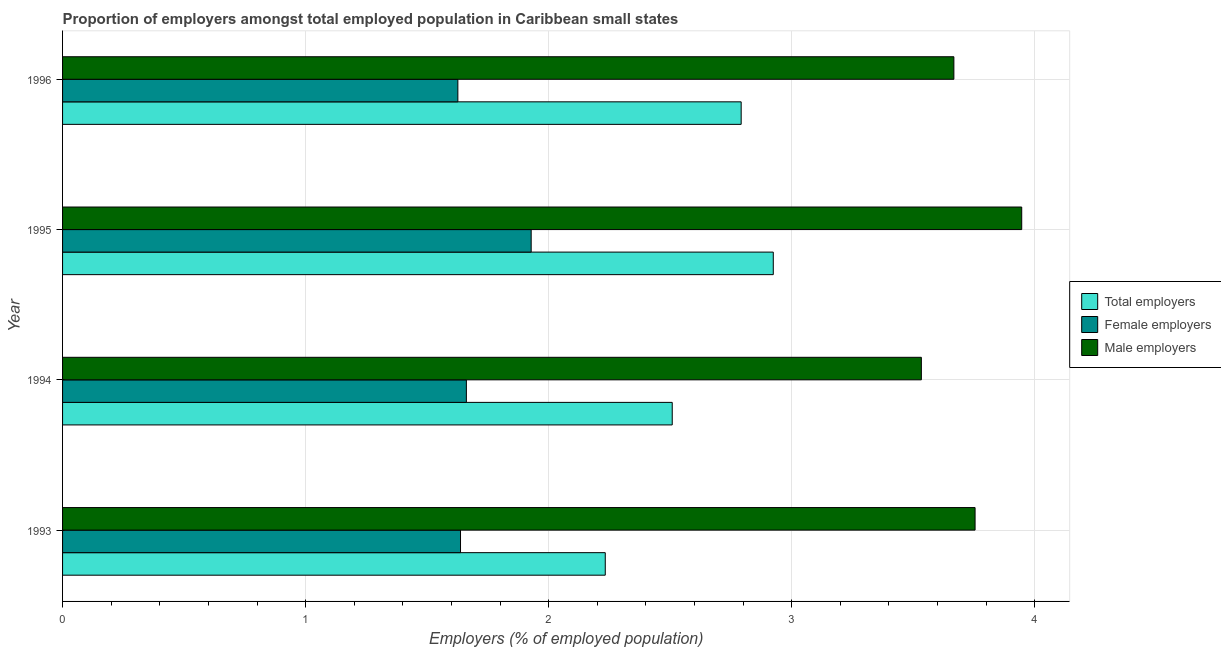Are the number of bars on each tick of the Y-axis equal?
Keep it short and to the point. Yes. How many bars are there on the 2nd tick from the top?
Offer a terse response. 3. How many bars are there on the 4th tick from the bottom?
Your response must be concise. 3. What is the label of the 1st group of bars from the top?
Offer a very short reply. 1996. What is the percentage of female employers in 1995?
Your answer should be very brief. 1.93. Across all years, what is the maximum percentage of male employers?
Your answer should be very brief. 3.95. Across all years, what is the minimum percentage of total employers?
Offer a terse response. 2.23. In which year was the percentage of female employers maximum?
Your answer should be compact. 1995. What is the total percentage of total employers in the graph?
Provide a succinct answer. 10.46. What is the difference between the percentage of female employers in 1993 and that in 1994?
Make the answer very short. -0.02. What is the difference between the percentage of male employers in 1994 and the percentage of female employers in 1996?
Provide a short and direct response. 1.91. What is the average percentage of female employers per year?
Provide a succinct answer. 1.71. In how many years, is the percentage of female employers greater than 3.2 %?
Give a very brief answer. 0. What is the ratio of the percentage of total employers in 1994 to that in 1996?
Give a very brief answer. 0.9. Is the percentage of female employers in 1993 less than that in 1996?
Offer a terse response. No. What is the difference between the highest and the second highest percentage of female employers?
Your answer should be compact. 0.27. What is the difference between the highest and the lowest percentage of total employers?
Your answer should be compact. 0.69. In how many years, is the percentage of female employers greater than the average percentage of female employers taken over all years?
Ensure brevity in your answer.  1. Is the sum of the percentage of total employers in 1995 and 1996 greater than the maximum percentage of male employers across all years?
Ensure brevity in your answer.  Yes. What does the 1st bar from the top in 1996 represents?
Keep it short and to the point. Male employers. What does the 2nd bar from the bottom in 1994 represents?
Provide a short and direct response. Female employers. How many bars are there?
Offer a very short reply. 12. Are all the bars in the graph horizontal?
Make the answer very short. Yes. How many years are there in the graph?
Your answer should be compact. 4. Does the graph contain any zero values?
Offer a very short reply. No. How are the legend labels stacked?
Make the answer very short. Vertical. What is the title of the graph?
Your answer should be compact. Proportion of employers amongst total employed population in Caribbean small states. Does "Communicable diseases" appear as one of the legend labels in the graph?
Provide a short and direct response. No. What is the label or title of the X-axis?
Offer a terse response. Employers (% of employed population). What is the Employers (% of employed population) in Total employers in 1993?
Make the answer very short. 2.23. What is the Employers (% of employed population) in Female employers in 1993?
Give a very brief answer. 1.64. What is the Employers (% of employed population) in Male employers in 1993?
Offer a terse response. 3.75. What is the Employers (% of employed population) of Total employers in 1994?
Your answer should be very brief. 2.51. What is the Employers (% of employed population) of Female employers in 1994?
Your answer should be compact. 1.66. What is the Employers (% of employed population) of Male employers in 1994?
Provide a succinct answer. 3.53. What is the Employers (% of employed population) of Total employers in 1995?
Make the answer very short. 2.92. What is the Employers (% of employed population) of Female employers in 1995?
Offer a very short reply. 1.93. What is the Employers (% of employed population) in Male employers in 1995?
Your answer should be very brief. 3.95. What is the Employers (% of employed population) of Total employers in 1996?
Your answer should be very brief. 2.79. What is the Employers (% of employed population) of Female employers in 1996?
Offer a very short reply. 1.63. What is the Employers (% of employed population) in Male employers in 1996?
Offer a very short reply. 3.67. Across all years, what is the maximum Employers (% of employed population) in Total employers?
Your answer should be compact. 2.92. Across all years, what is the maximum Employers (% of employed population) of Female employers?
Your response must be concise. 1.93. Across all years, what is the maximum Employers (% of employed population) in Male employers?
Your answer should be compact. 3.95. Across all years, what is the minimum Employers (% of employed population) in Total employers?
Your answer should be very brief. 2.23. Across all years, what is the minimum Employers (% of employed population) of Female employers?
Your answer should be compact. 1.63. Across all years, what is the minimum Employers (% of employed population) of Male employers?
Make the answer very short. 3.53. What is the total Employers (% of employed population) in Total employers in the graph?
Offer a very short reply. 10.46. What is the total Employers (% of employed population) of Female employers in the graph?
Ensure brevity in your answer.  6.85. What is the total Employers (% of employed population) of Male employers in the graph?
Provide a short and direct response. 14.9. What is the difference between the Employers (% of employed population) of Total employers in 1993 and that in 1994?
Offer a terse response. -0.28. What is the difference between the Employers (% of employed population) of Female employers in 1993 and that in 1994?
Ensure brevity in your answer.  -0.02. What is the difference between the Employers (% of employed population) of Male employers in 1993 and that in 1994?
Ensure brevity in your answer.  0.22. What is the difference between the Employers (% of employed population) of Total employers in 1993 and that in 1995?
Make the answer very short. -0.69. What is the difference between the Employers (% of employed population) in Female employers in 1993 and that in 1995?
Provide a short and direct response. -0.29. What is the difference between the Employers (% of employed population) in Male employers in 1993 and that in 1995?
Offer a terse response. -0.19. What is the difference between the Employers (% of employed population) in Total employers in 1993 and that in 1996?
Your response must be concise. -0.56. What is the difference between the Employers (% of employed population) in Female employers in 1993 and that in 1996?
Give a very brief answer. 0.01. What is the difference between the Employers (% of employed population) in Male employers in 1993 and that in 1996?
Make the answer very short. 0.09. What is the difference between the Employers (% of employed population) in Total employers in 1994 and that in 1995?
Give a very brief answer. -0.42. What is the difference between the Employers (% of employed population) of Female employers in 1994 and that in 1995?
Provide a short and direct response. -0.27. What is the difference between the Employers (% of employed population) in Male employers in 1994 and that in 1995?
Your answer should be very brief. -0.41. What is the difference between the Employers (% of employed population) of Total employers in 1994 and that in 1996?
Offer a very short reply. -0.28. What is the difference between the Employers (% of employed population) in Female employers in 1994 and that in 1996?
Your answer should be very brief. 0.04. What is the difference between the Employers (% of employed population) in Male employers in 1994 and that in 1996?
Provide a short and direct response. -0.13. What is the difference between the Employers (% of employed population) of Total employers in 1995 and that in 1996?
Offer a very short reply. 0.13. What is the difference between the Employers (% of employed population) of Female employers in 1995 and that in 1996?
Your answer should be compact. 0.3. What is the difference between the Employers (% of employed population) of Male employers in 1995 and that in 1996?
Your response must be concise. 0.28. What is the difference between the Employers (% of employed population) in Total employers in 1993 and the Employers (% of employed population) in Male employers in 1994?
Provide a short and direct response. -1.3. What is the difference between the Employers (% of employed population) of Female employers in 1993 and the Employers (% of employed population) of Male employers in 1994?
Make the answer very short. -1.9. What is the difference between the Employers (% of employed population) in Total employers in 1993 and the Employers (% of employed population) in Female employers in 1995?
Keep it short and to the point. 0.3. What is the difference between the Employers (% of employed population) in Total employers in 1993 and the Employers (% of employed population) in Male employers in 1995?
Your answer should be very brief. -1.71. What is the difference between the Employers (% of employed population) of Female employers in 1993 and the Employers (% of employed population) of Male employers in 1995?
Your response must be concise. -2.31. What is the difference between the Employers (% of employed population) of Total employers in 1993 and the Employers (% of employed population) of Female employers in 1996?
Give a very brief answer. 0.61. What is the difference between the Employers (% of employed population) in Total employers in 1993 and the Employers (% of employed population) in Male employers in 1996?
Offer a very short reply. -1.43. What is the difference between the Employers (% of employed population) of Female employers in 1993 and the Employers (% of employed population) of Male employers in 1996?
Your answer should be compact. -2.03. What is the difference between the Employers (% of employed population) of Total employers in 1994 and the Employers (% of employed population) of Female employers in 1995?
Give a very brief answer. 0.58. What is the difference between the Employers (% of employed population) of Total employers in 1994 and the Employers (% of employed population) of Male employers in 1995?
Ensure brevity in your answer.  -1.44. What is the difference between the Employers (% of employed population) in Female employers in 1994 and the Employers (% of employed population) in Male employers in 1995?
Ensure brevity in your answer.  -2.28. What is the difference between the Employers (% of employed population) in Total employers in 1994 and the Employers (% of employed population) in Female employers in 1996?
Ensure brevity in your answer.  0.88. What is the difference between the Employers (% of employed population) in Total employers in 1994 and the Employers (% of employed population) in Male employers in 1996?
Offer a very short reply. -1.16. What is the difference between the Employers (% of employed population) in Female employers in 1994 and the Employers (% of employed population) in Male employers in 1996?
Ensure brevity in your answer.  -2.01. What is the difference between the Employers (% of employed population) of Total employers in 1995 and the Employers (% of employed population) of Female employers in 1996?
Give a very brief answer. 1.3. What is the difference between the Employers (% of employed population) in Total employers in 1995 and the Employers (% of employed population) in Male employers in 1996?
Provide a succinct answer. -0.74. What is the difference between the Employers (% of employed population) in Female employers in 1995 and the Employers (% of employed population) in Male employers in 1996?
Your response must be concise. -1.74. What is the average Employers (% of employed population) of Total employers per year?
Provide a short and direct response. 2.61. What is the average Employers (% of employed population) of Female employers per year?
Offer a terse response. 1.71. What is the average Employers (% of employed population) of Male employers per year?
Provide a succinct answer. 3.73. In the year 1993, what is the difference between the Employers (% of employed population) in Total employers and Employers (% of employed population) in Female employers?
Provide a succinct answer. 0.6. In the year 1993, what is the difference between the Employers (% of employed population) in Total employers and Employers (% of employed population) in Male employers?
Offer a terse response. -1.52. In the year 1993, what is the difference between the Employers (% of employed population) in Female employers and Employers (% of employed population) in Male employers?
Make the answer very short. -2.12. In the year 1994, what is the difference between the Employers (% of employed population) in Total employers and Employers (% of employed population) in Female employers?
Keep it short and to the point. 0.85. In the year 1994, what is the difference between the Employers (% of employed population) in Total employers and Employers (% of employed population) in Male employers?
Ensure brevity in your answer.  -1.02. In the year 1994, what is the difference between the Employers (% of employed population) of Female employers and Employers (% of employed population) of Male employers?
Give a very brief answer. -1.87. In the year 1995, what is the difference between the Employers (% of employed population) in Total employers and Employers (% of employed population) in Female employers?
Your answer should be very brief. 1. In the year 1995, what is the difference between the Employers (% of employed population) of Total employers and Employers (% of employed population) of Male employers?
Provide a short and direct response. -1.02. In the year 1995, what is the difference between the Employers (% of employed population) of Female employers and Employers (% of employed population) of Male employers?
Give a very brief answer. -2.02. In the year 1996, what is the difference between the Employers (% of employed population) in Total employers and Employers (% of employed population) in Female employers?
Give a very brief answer. 1.17. In the year 1996, what is the difference between the Employers (% of employed population) in Total employers and Employers (% of employed population) in Male employers?
Your response must be concise. -0.88. In the year 1996, what is the difference between the Employers (% of employed population) in Female employers and Employers (% of employed population) in Male employers?
Make the answer very short. -2.04. What is the ratio of the Employers (% of employed population) in Total employers in 1993 to that in 1994?
Make the answer very short. 0.89. What is the ratio of the Employers (% of employed population) of Female employers in 1993 to that in 1994?
Your answer should be very brief. 0.99. What is the ratio of the Employers (% of employed population) of Male employers in 1993 to that in 1994?
Provide a short and direct response. 1.06. What is the ratio of the Employers (% of employed population) in Total employers in 1993 to that in 1995?
Keep it short and to the point. 0.76. What is the ratio of the Employers (% of employed population) of Female employers in 1993 to that in 1995?
Ensure brevity in your answer.  0.85. What is the ratio of the Employers (% of employed population) in Male employers in 1993 to that in 1995?
Your answer should be very brief. 0.95. What is the ratio of the Employers (% of employed population) of Total employers in 1993 to that in 1996?
Make the answer very short. 0.8. What is the ratio of the Employers (% of employed population) of Male employers in 1993 to that in 1996?
Offer a very short reply. 1.02. What is the ratio of the Employers (% of employed population) in Total employers in 1994 to that in 1995?
Make the answer very short. 0.86. What is the ratio of the Employers (% of employed population) of Female employers in 1994 to that in 1995?
Keep it short and to the point. 0.86. What is the ratio of the Employers (% of employed population) in Male employers in 1994 to that in 1995?
Offer a very short reply. 0.9. What is the ratio of the Employers (% of employed population) in Total employers in 1994 to that in 1996?
Offer a terse response. 0.9. What is the ratio of the Employers (% of employed population) in Female employers in 1994 to that in 1996?
Offer a terse response. 1.02. What is the ratio of the Employers (% of employed population) in Male employers in 1994 to that in 1996?
Offer a very short reply. 0.96. What is the ratio of the Employers (% of employed population) in Total employers in 1995 to that in 1996?
Your response must be concise. 1.05. What is the ratio of the Employers (% of employed population) in Female employers in 1995 to that in 1996?
Make the answer very short. 1.19. What is the ratio of the Employers (% of employed population) of Male employers in 1995 to that in 1996?
Ensure brevity in your answer.  1.08. What is the difference between the highest and the second highest Employers (% of employed population) of Total employers?
Offer a very short reply. 0.13. What is the difference between the highest and the second highest Employers (% of employed population) in Female employers?
Your response must be concise. 0.27. What is the difference between the highest and the second highest Employers (% of employed population) of Male employers?
Give a very brief answer. 0.19. What is the difference between the highest and the lowest Employers (% of employed population) of Total employers?
Offer a very short reply. 0.69. What is the difference between the highest and the lowest Employers (% of employed population) of Female employers?
Offer a very short reply. 0.3. What is the difference between the highest and the lowest Employers (% of employed population) in Male employers?
Keep it short and to the point. 0.41. 